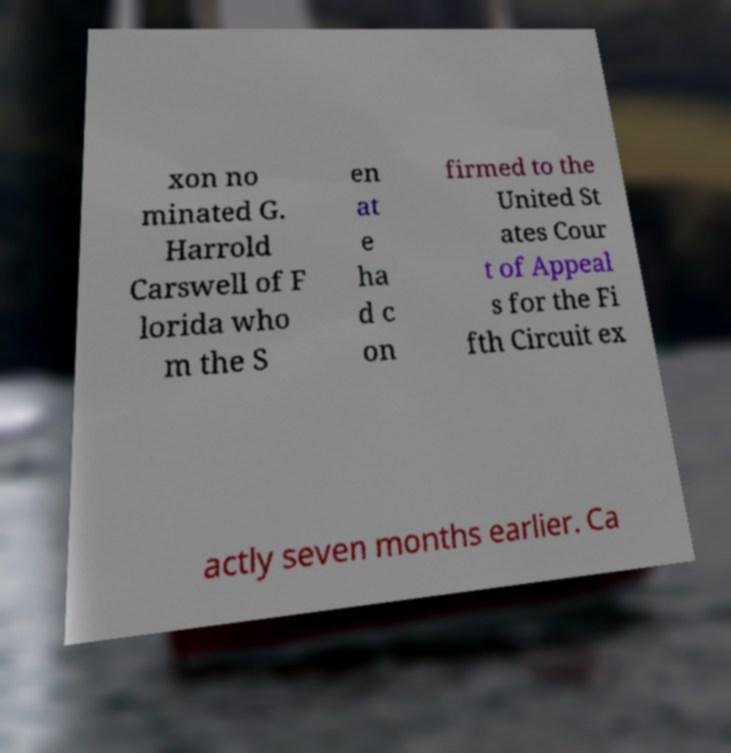Please read and relay the text visible in this image. What does it say? xon no minated G. Harrold Carswell of F lorida who m the S en at e ha d c on firmed to the United St ates Cour t of Appeal s for the Fi fth Circuit ex actly seven months earlier. Ca 